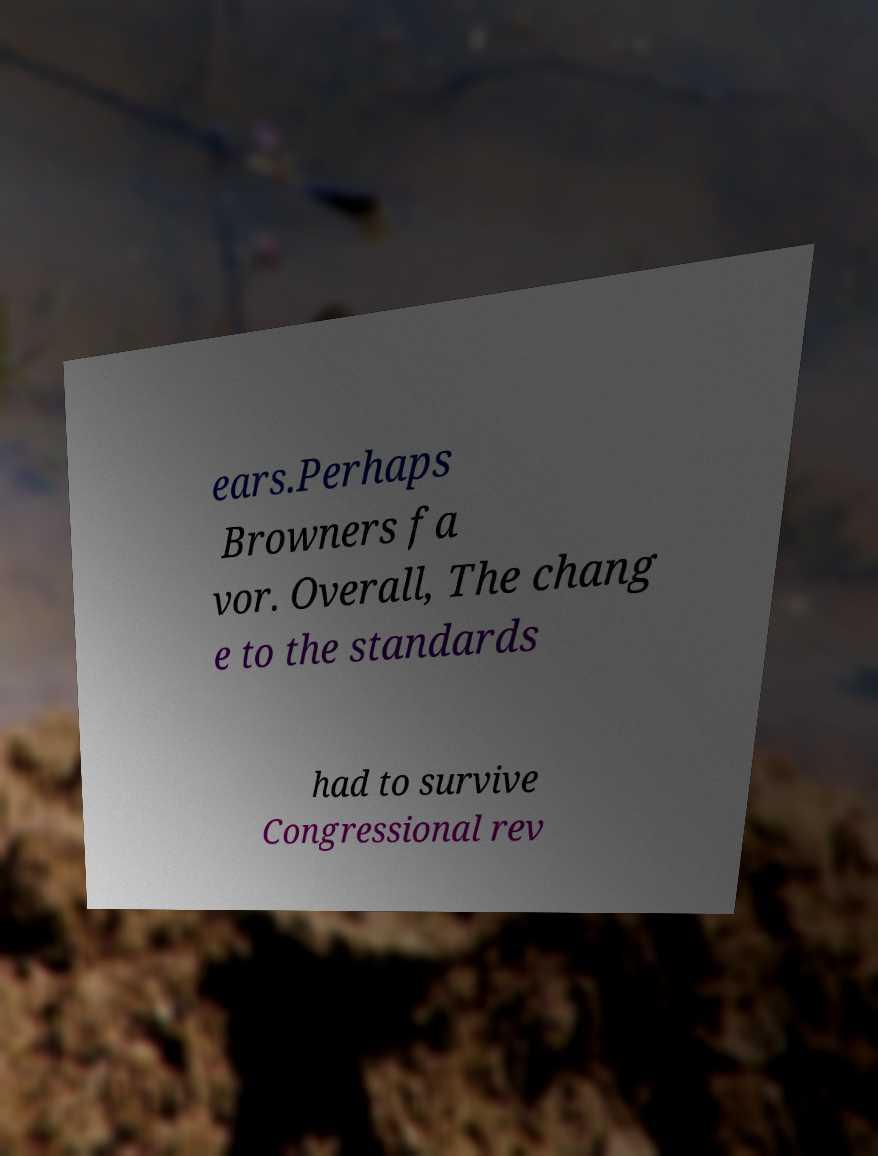Can you accurately transcribe the text from the provided image for me? ears.Perhaps Browners fa vor. Overall, The chang e to the standards had to survive Congressional rev 